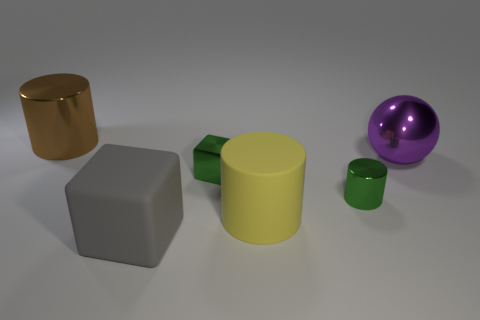Do the small metal cylinder and the tiny cube have the same color?
Provide a succinct answer. Yes. Are there any objects behind the green cube?
Make the answer very short. Yes. How big is the metal block?
Provide a succinct answer. Small. What is the size of the green thing that is the same shape as the large yellow thing?
Ensure brevity in your answer.  Small. There is a block that is in front of the tiny green metal block; how many large matte objects are behind it?
Your answer should be very brief. 1. Are the cylinder behind the purple sphere and the big cylinder in front of the large purple thing made of the same material?
Your response must be concise. No. What number of large rubber things are the same shape as the brown metallic thing?
Offer a terse response. 1. What number of other cylinders are the same color as the matte cylinder?
Make the answer very short. 0. There is a green object that is on the right side of the big yellow thing; does it have the same shape as the big metal object left of the big matte block?
Your response must be concise. Yes. There is a green cylinder that is to the right of the big cylinder that is to the left of the tiny block; how many large cubes are behind it?
Provide a succinct answer. 0. 